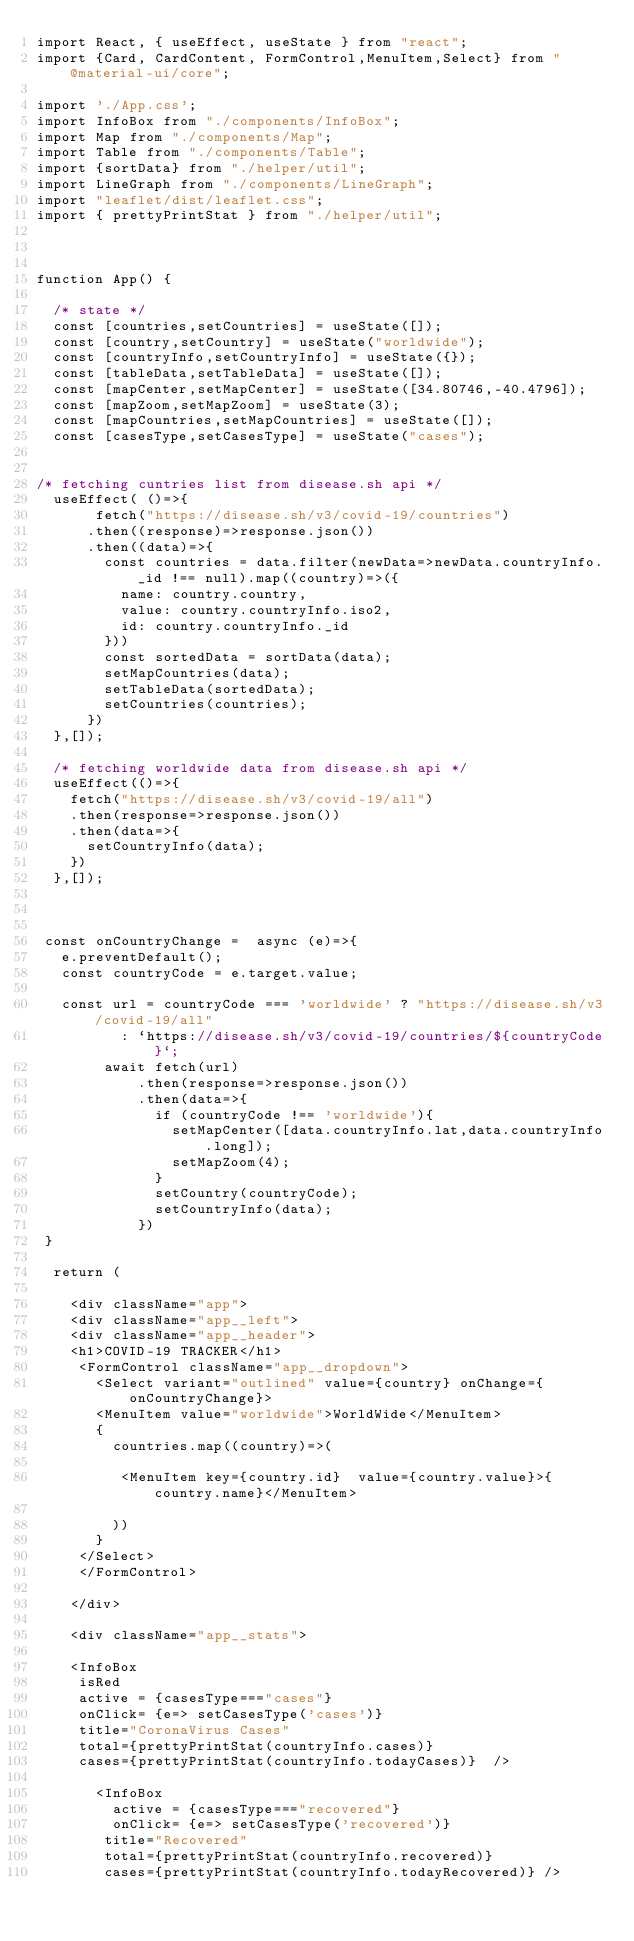Convert code to text. <code><loc_0><loc_0><loc_500><loc_500><_JavaScript_>import React, { useEffect, useState } from "react";
import {Card, CardContent, FormControl,MenuItem,Select} from "@material-ui/core";

import './App.css';
import InfoBox from "./components/InfoBox";
import Map from "./components/Map";
import Table from "./components/Table";
import {sortData} from "./helper/util";
import LineGraph from "./components/LineGraph";
import "leaflet/dist/leaflet.css";
import { prettyPrintStat } from "./helper/util";



function App() {

  /* state */
  const [countries,setCountries] = useState([]);
  const [country,setCountry] = useState("worldwide");
  const [countryInfo,setCountryInfo] = useState({});
  const [tableData,setTableData] = useState([]);
  const [mapCenter,setMapCenter] = useState([34.80746,-40.4796]);
  const [mapZoom,setMapZoom] = useState(3);
  const [mapCountries,setMapCountries] = useState([]);
  const [casesType,setCasesType] = useState("cases");


/* fetching cuntries list from disease.sh api */
  useEffect( ()=>{
       fetch("https://disease.sh/v3/covid-19/countries")
      .then((response)=>response.json())
      .then((data)=>{
        const countries = data.filter(newData=>newData.countryInfo._id !== null).map((country)=>({
          name: country.country,
          value: country.countryInfo.iso2,
          id: country.countryInfo._id
        }))
        const sortedData = sortData(data);
        setMapCountries(data);
        setTableData(sortedData);
        setCountries(countries);
      })
  },[]);

  /* fetching worldwide data from disease.sh api */
  useEffect(()=>{
    fetch("https://disease.sh/v3/covid-19/all")
    .then(response=>response.json())
    .then(data=>{
      setCountryInfo(data);
    })
  },[]);

 

 const onCountryChange =  async (e)=>{
   e.preventDefault();
   const countryCode = e.target.value;
   
   const url = countryCode === 'worldwide' ? "https://disease.sh/v3/covid-19/all" 
          : `https://disease.sh/v3/covid-19/countries/${countryCode}`;
        await fetch(url)
            .then(response=>response.json())
            .then(data=>{
              if (countryCode !== 'worldwide'){
                setMapCenter([data.countryInfo.lat,data.countryInfo.long]);
                setMapZoom(4);
              }
              setCountry(countryCode);
              setCountryInfo(data);
            })
 }

  return (
    
    <div className="app">
    <div className="app__left">
    <div className="app__header">
    <h1>COVID-19 TRACKER</h1>
     <FormControl className="app__dropdown">
       <Select variant="outlined" value={country} onChange={onCountryChange}>
       <MenuItem value="worldwide">WorldWide</MenuItem>
       {
         countries.map((country)=>(
          
          <MenuItem key={country.id}  value={country.value}>{country.name}</MenuItem>
        
         ))
       }
     </Select>
     </FormControl>

    </div>

    <div className="app__stats">

    <InfoBox
     isRed
     active = {casesType==="cases"}
     onClick= {e=> setCasesType('cases')}
     title="CoronaVirus Cases"
     total={prettyPrintStat(countryInfo.cases)} 
     cases={prettyPrintStat(countryInfo.todayCases)}  />

       <InfoBox
         active = {casesType==="recovered"}
         onClick= {e=> setCasesType('recovered')}
        title="Recovered"
        total={prettyPrintStat(countryInfo.recovered)} 
        cases={prettyPrintStat(countryInfo.todayRecovered)} />
</code> 